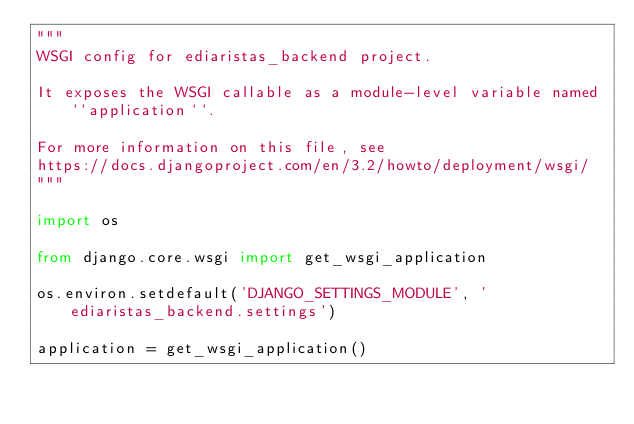<code> <loc_0><loc_0><loc_500><loc_500><_Python_>"""
WSGI config for ediaristas_backend project.

It exposes the WSGI callable as a module-level variable named ``application``.

For more information on this file, see
https://docs.djangoproject.com/en/3.2/howto/deployment/wsgi/
"""

import os

from django.core.wsgi import get_wsgi_application

os.environ.setdefault('DJANGO_SETTINGS_MODULE', 'ediaristas_backend.settings')

application = get_wsgi_application()
</code> 